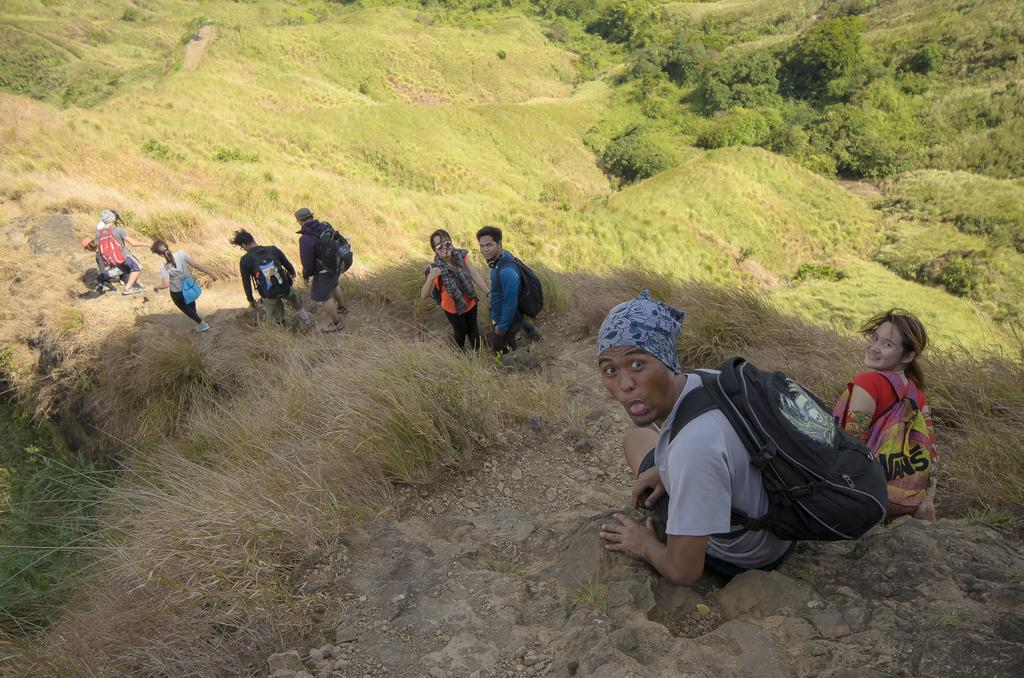How many people are in the image? There is a group of people in the image. What is the surface the people are standing on? The people are on grass. What type of natural features can be seen in the image? There are trees and mountains in the image. Can you determine the time of day the image was taken? The image might have been taken during the day. What color is the daughter's van in the image? There is no daughter or van present in the image. 